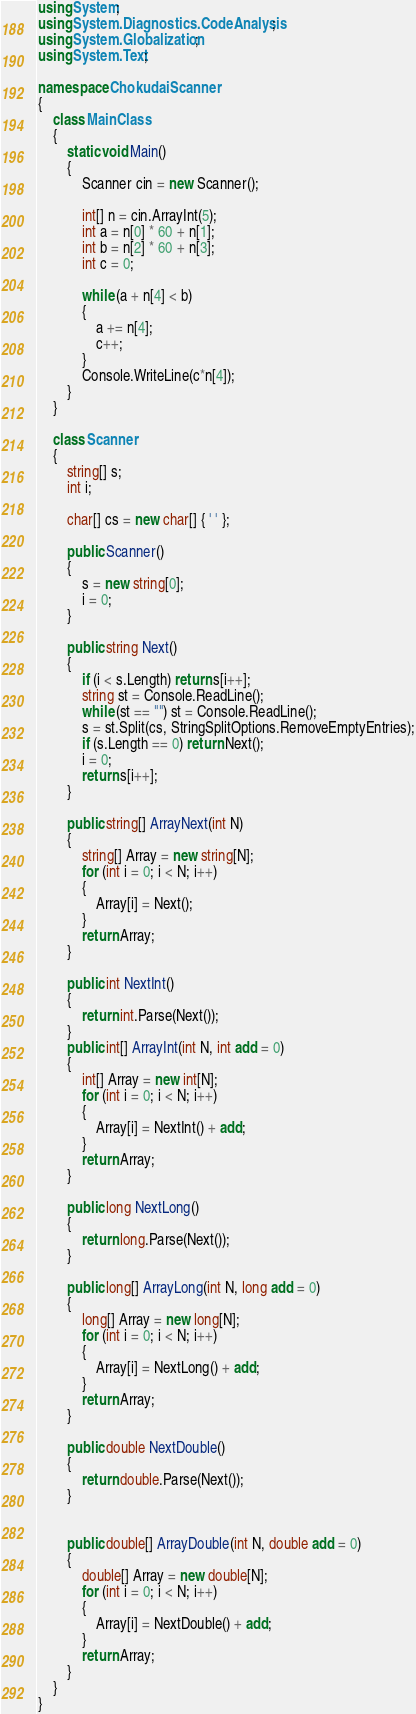Convert code to text. <code><loc_0><loc_0><loc_500><loc_500><_C#_>using System;
using System.Diagnostics.CodeAnalysis;
using System.Globalization;
using System.Text;

namespace ChokudaiScanner
{
    class MainClass
    {
        static void Main()
        {
            Scanner cin = new Scanner();

            int[] n = cin.ArrayInt(5);
            int a = n[0] * 60 + n[1];
            int b = n[2] * 60 + n[3];
            int c = 0;

            while (a + n[4] < b)
            {
                a += n[4];
                c++;
            }
            Console.WriteLine(c*n[4]);
        }
    }

    class Scanner
    {
        string[] s;
        int i;

        char[] cs = new char[] { ' ' };

        public Scanner()
        {
            s = new string[0];
            i = 0;
        }

        public string Next()
        {
            if (i < s.Length) return s[i++];
            string st = Console.ReadLine();
            while (st == "") st = Console.ReadLine();
            s = st.Split(cs, StringSplitOptions.RemoveEmptyEntries);
            if (s.Length == 0) return Next();
            i = 0;
            return s[i++];
        }

        public string[] ArrayNext(int N)
        {
            string[] Array = new string[N];
            for (int i = 0; i < N; i++)
            {
                Array[i] = Next();
            }
            return Array;
        }

        public int NextInt()
        {
            return int.Parse(Next());
        }
        public int[] ArrayInt(int N, int add = 0)
        {
            int[] Array = new int[N];
            for (int i = 0; i < N; i++)
            {
                Array[i] = NextInt() + add;
            }
            return Array;
        }

        public long NextLong()
        {
            return long.Parse(Next());
        }

        public long[] ArrayLong(int N, long add = 0)
        {
            long[] Array = new long[N];
            for (int i = 0; i < N; i++)
            {
                Array[i] = NextLong() + add;
            }
            return Array;
        }

        public double NextDouble()
        {
            return double.Parse(Next());
        }


        public double[] ArrayDouble(int N, double add = 0)
        {
            double[] Array = new double[N];
            for (int i = 0; i < N; i++)
            {
                Array[i] = NextDouble() + add;
            }
            return Array;
        }
    }
}

</code> 